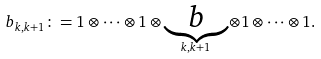<formula> <loc_0><loc_0><loc_500><loc_500>b _ { k , k + 1 } \colon = 1 \otimes \cdots \otimes 1 \otimes \underbrace { b } _ { k , k + 1 } \otimes 1 \otimes \cdots \otimes 1 .</formula> 